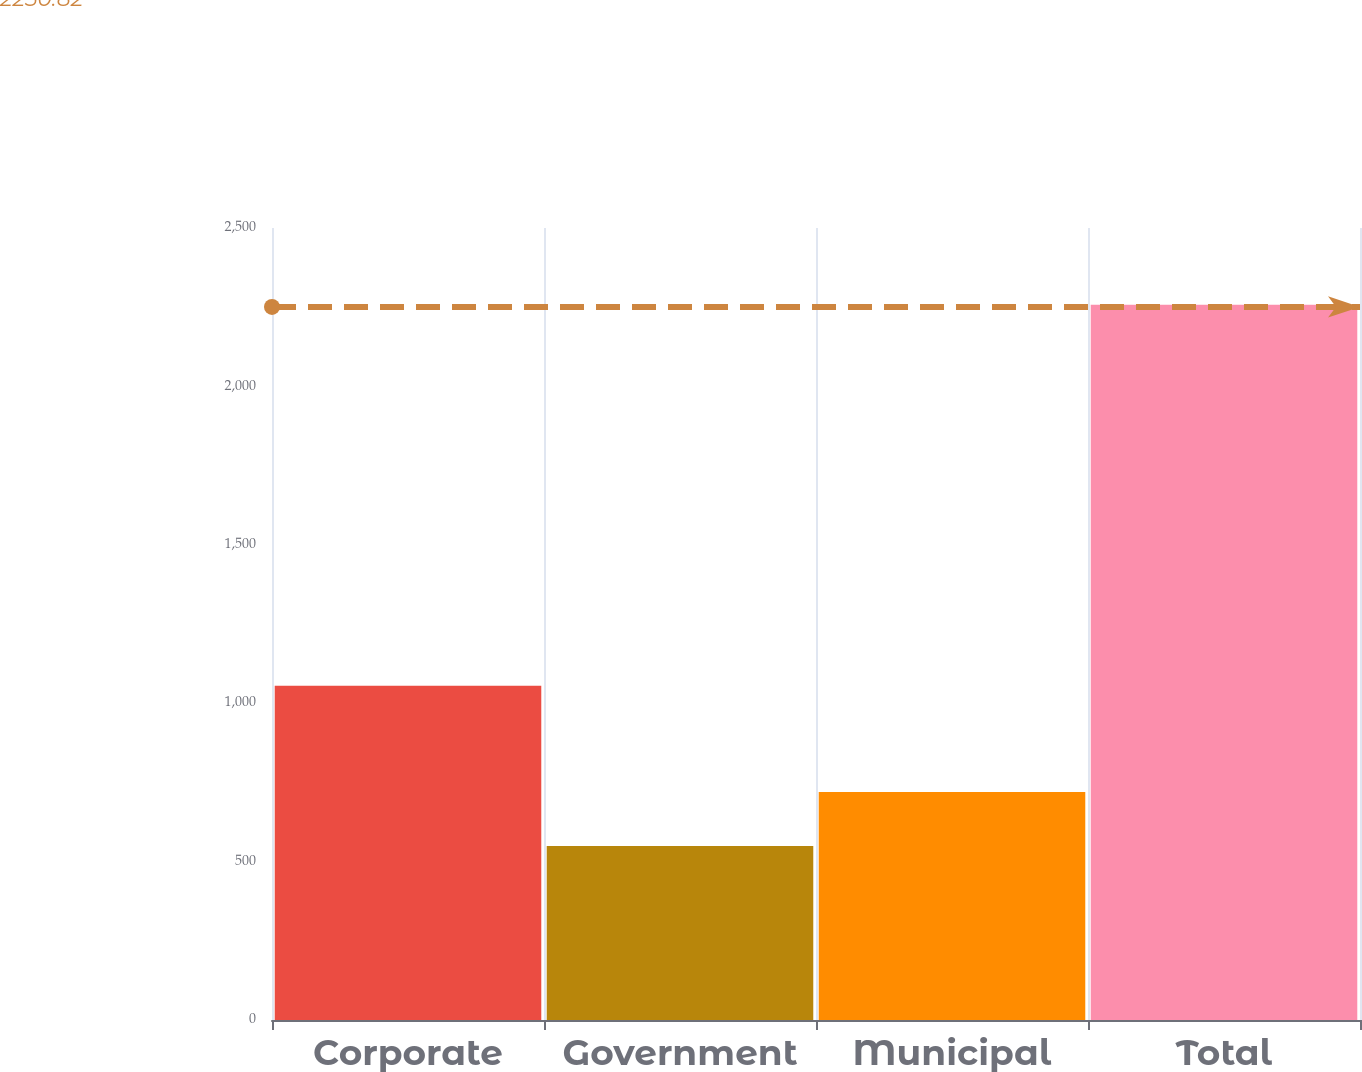Convert chart. <chart><loc_0><loc_0><loc_500><loc_500><bar_chart><fcel>Corporate<fcel>Government<fcel>Municipal<fcel>Total<nl><fcel>1055<fcel>549<fcel>719.9<fcel>2258<nl></chart> 